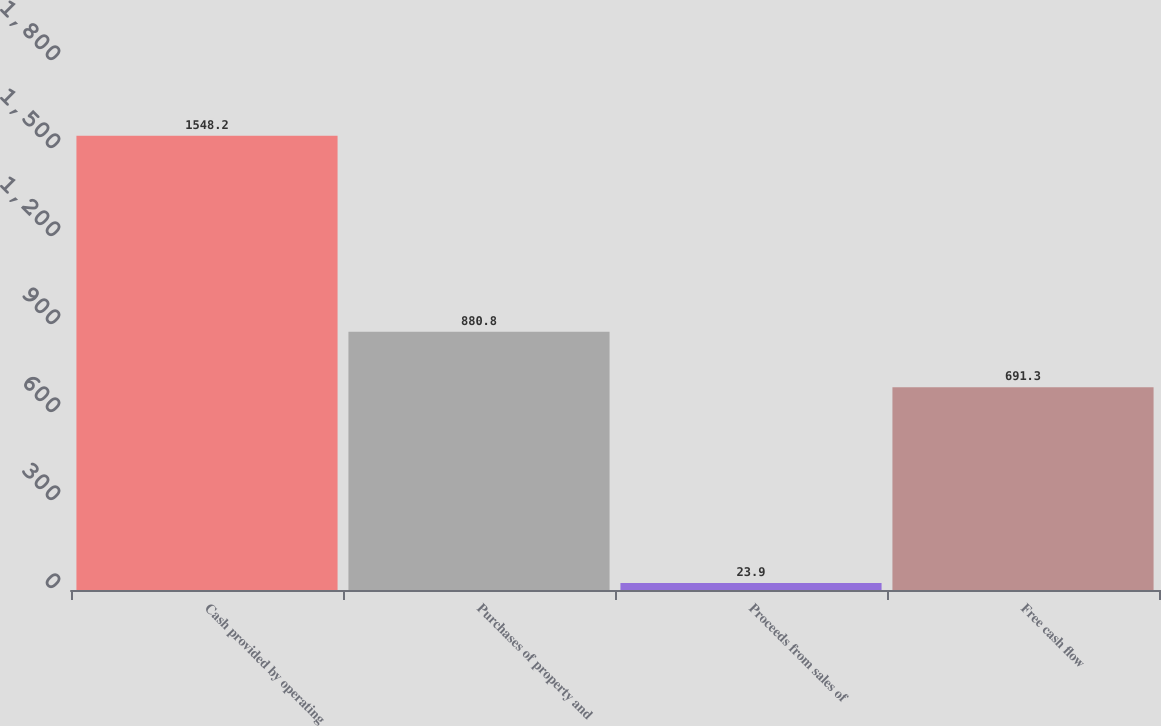Convert chart to OTSL. <chart><loc_0><loc_0><loc_500><loc_500><bar_chart><fcel>Cash provided by operating<fcel>Purchases of property and<fcel>Proceeds from sales of<fcel>Free cash flow<nl><fcel>1548.2<fcel>880.8<fcel>23.9<fcel>691.3<nl></chart> 